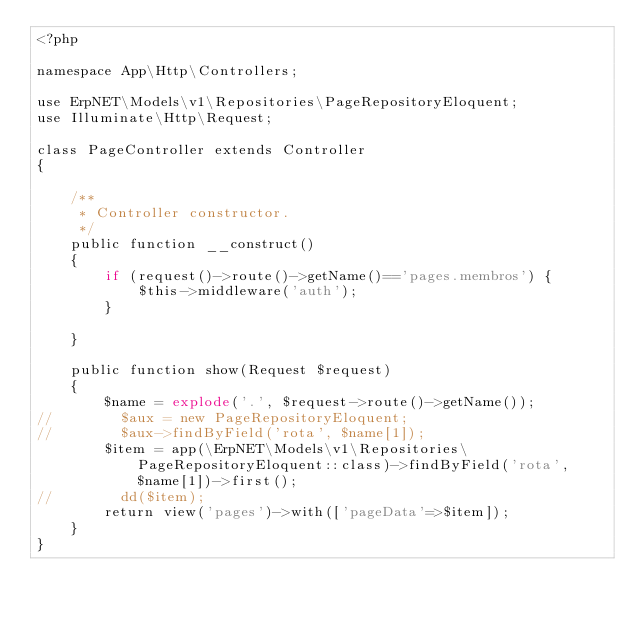<code> <loc_0><loc_0><loc_500><loc_500><_PHP_><?php

namespace App\Http\Controllers;

use ErpNET\Models\v1\Repositories\PageRepositoryEloquent;
use Illuminate\Http\Request;

class PageController extends Controller
{

    /**
     * Controller constructor.
     */
    public function __construct()
    {
        if (request()->route()->getName()=='pages.membros') {
            $this->middleware('auth');
        }

    }

    public function show(Request $request)
    {
        $name = explode('.', $request->route()->getName());
//        $aux = new PageRepositoryEloquent;
//        $aux->findByField('rota', $name[1]);
        $item = app(\ErpNET\Models\v1\Repositories\PageRepositoryEloquent::class)->findByField('rota', $name[1])->first();
//        dd($item);
        return view('pages')->with(['pageData'=>$item]);
    }
}
</code> 